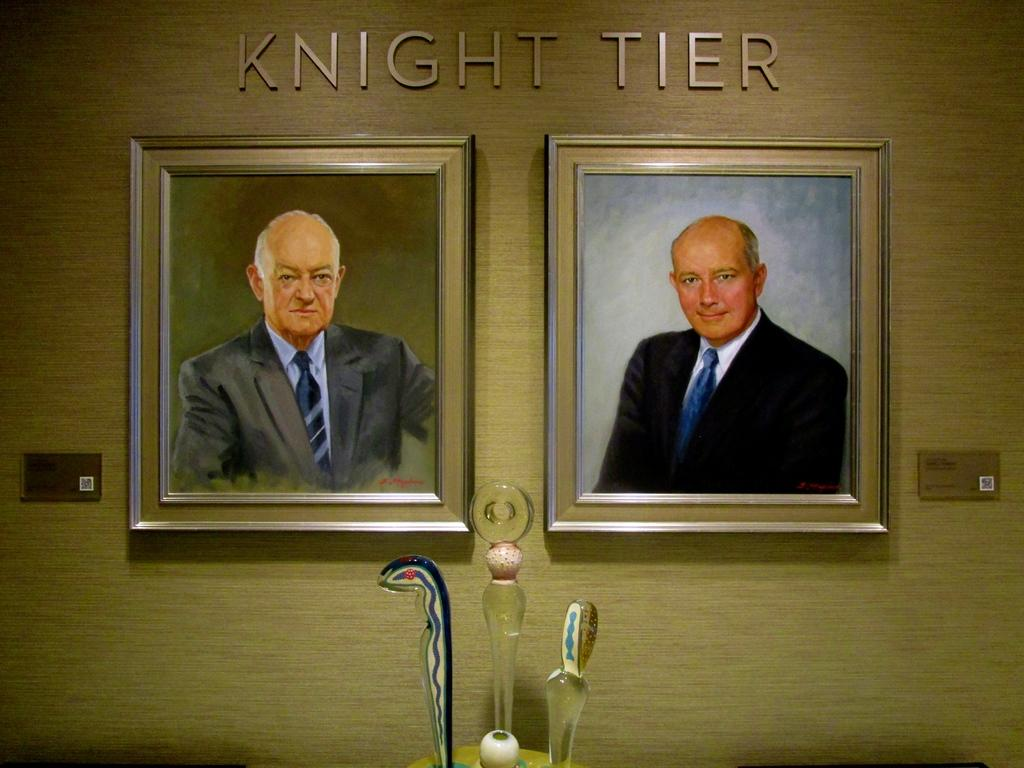Provide a one-sentence caption for the provided image. Two pictures of men under the words "Knight Tier". 